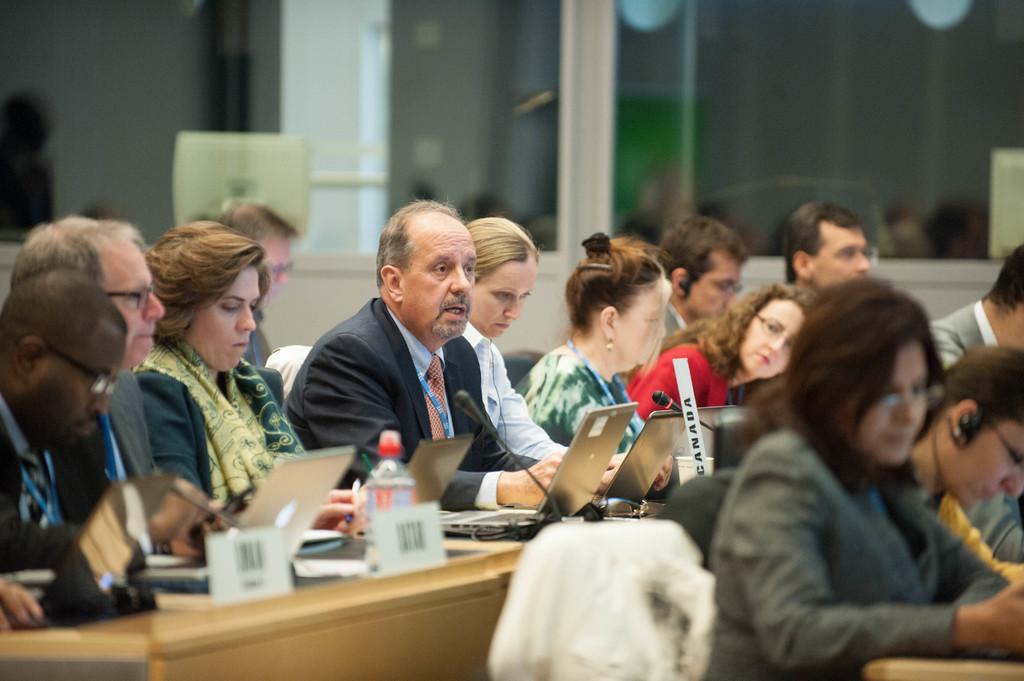In one or two sentences, can you explain what this image depicts? In this image there are group of persons sitting, there are desks, there are objects on the desk, there is the wall, there is a pillar towards the top of the image, there are lights towards the top of the image, there is an object towards the right of the image, there is an object towards the bottom of the image. 